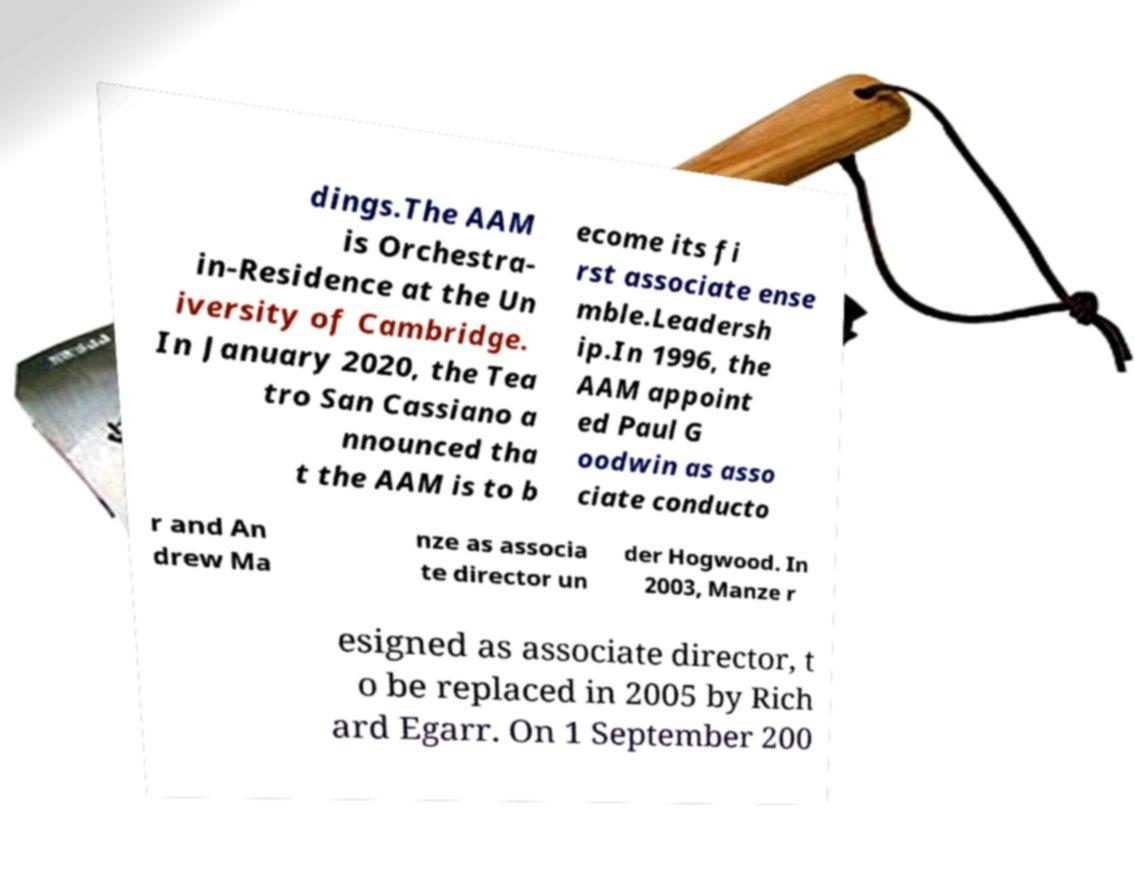What messages or text are displayed in this image? I need them in a readable, typed format. dings.The AAM is Orchestra- in-Residence at the Un iversity of Cambridge. In January 2020, the Tea tro San Cassiano a nnounced tha t the AAM is to b ecome its fi rst associate ense mble.Leadersh ip.In 1996, the AAM appoint ed Paul G oodwin as asso ciate conducto r and An drew Ma nze as associa te director un der Hogwood. In 2003, Manze r esigned as associate director, t o be replaced in 2005 by Rich ard Egarr. On 1 September 200 